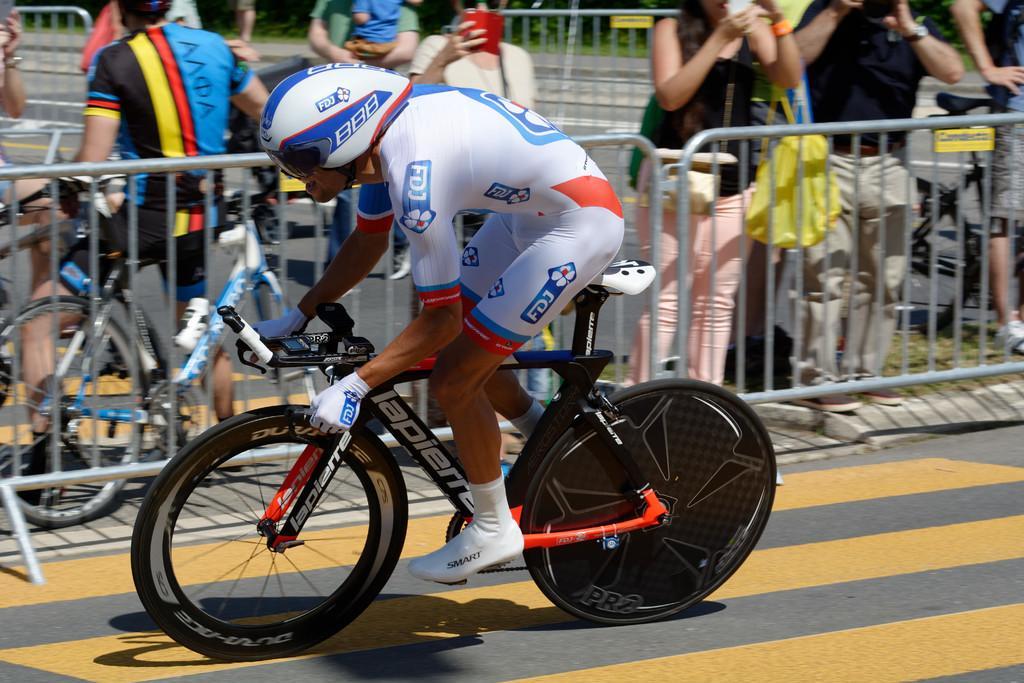How would you summarize this image in a sentence or two? As we can see in the image there are few people here and there and in the front there is a man riding bicycle. 